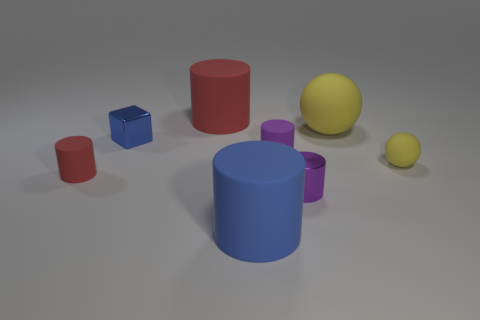What number of yellow objects are tiny metallic cylinders or big rubber balls?
Offer a terse response. 1. Does the tiny yellow ball behind the small purple metal cylinder have the same material as the small blue thing?
Offer a very short reply. No. What number of things are large red cylinders or cylinders that are on the right side of the big blue cylinder?
Provide a short and direct response. 3. There is a small yellow matte thing right of the metal object that is to the left of the small purple rubber cylinder; how many yellow objects are behind it?
Your answer should be very brief. 1. Does the large blue thing in front of the big red object have the same shape as the tiny purple matte object?
Make the answer very short. Yes. Are there any red matte objects that are on the left side of the big rubber object that is left of the large blue rubber cylinder?
Make the answer very short. Yes. How many cyan rubber spheres are there?
Your response must be concise. 0. There is a tiny object that is both right of the tiny red cylinder and left of the large red object; what color is it?
Your response must be concise. Blue. The blue thing that is the same shape as the big red thing is what size?
Your answer should be compact. Large. What number of other cylinders are the same size as the blue rubber cylinder?
Your answer should be compact. 1. 